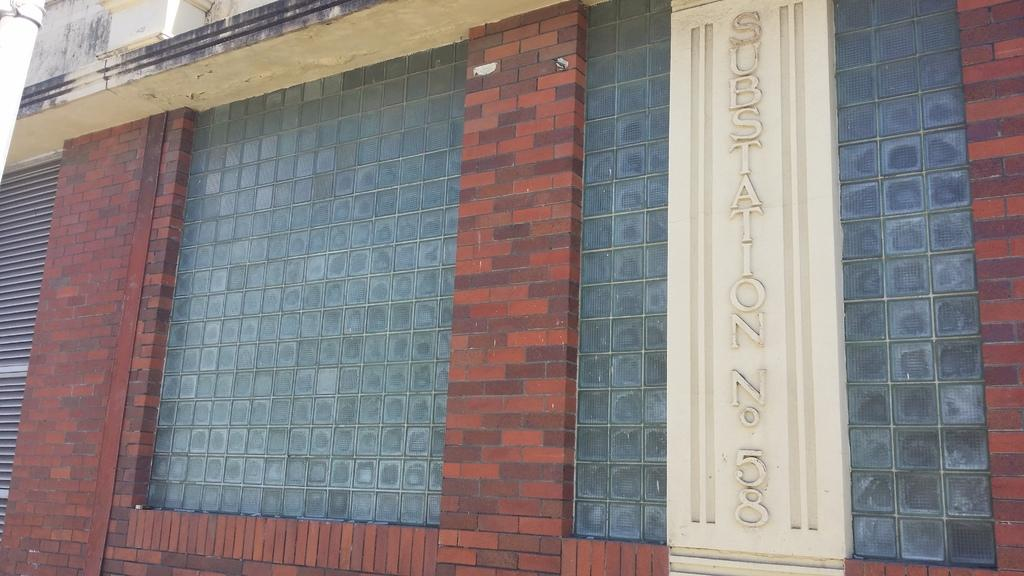What type of structure is visible in the image? There is a building in the image. Can you describe any specific features of the building? There is text on the wall of the building. How many wheels are attached to the building in the image? There are no wheels present on the building in the image. What advice does the father give in the image? There is no father or advice present in the image; it only features a building with text on the wall. 